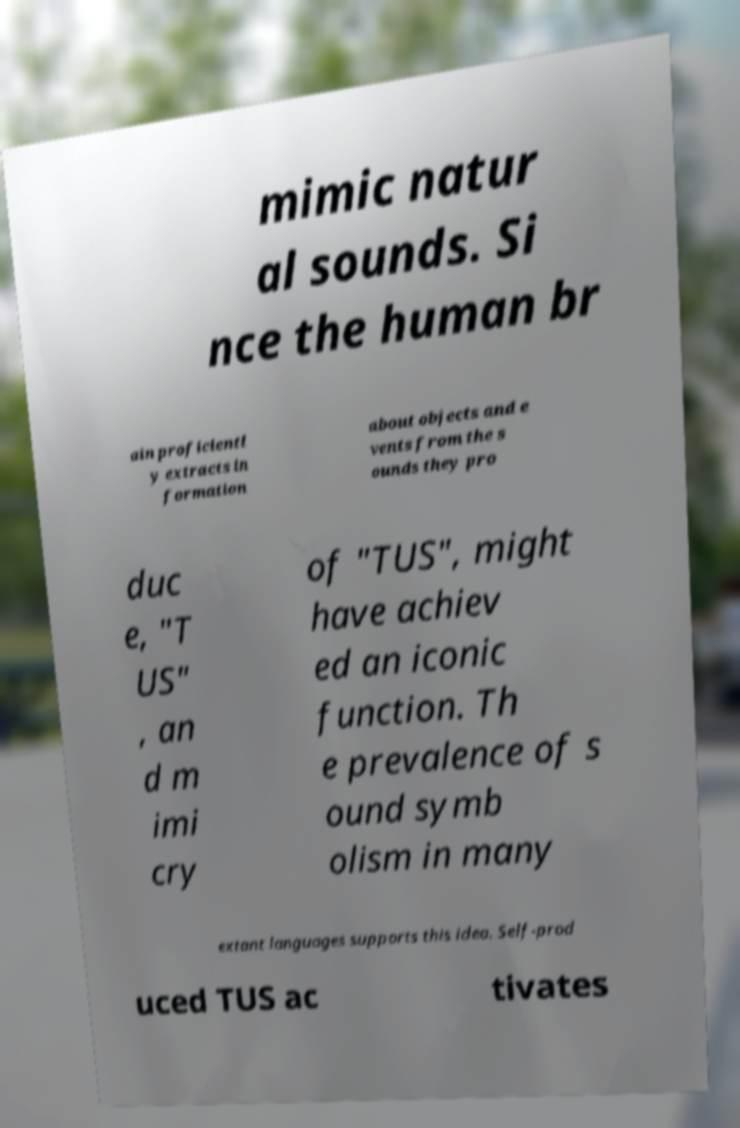I need the written content from this picture converted into text. Can you do that? mimic natur al sounds. Si nce the human br ain proficientl y extracts in formation about objects and e vents from the s ounds they pro duc e, "T US" , an d m imi cry of "TUS", might have achiev ed an iconic function. Th e prevalence of s ound symb olism in many extant languages supports this idea. Self-prod uced TUS ac tivates 